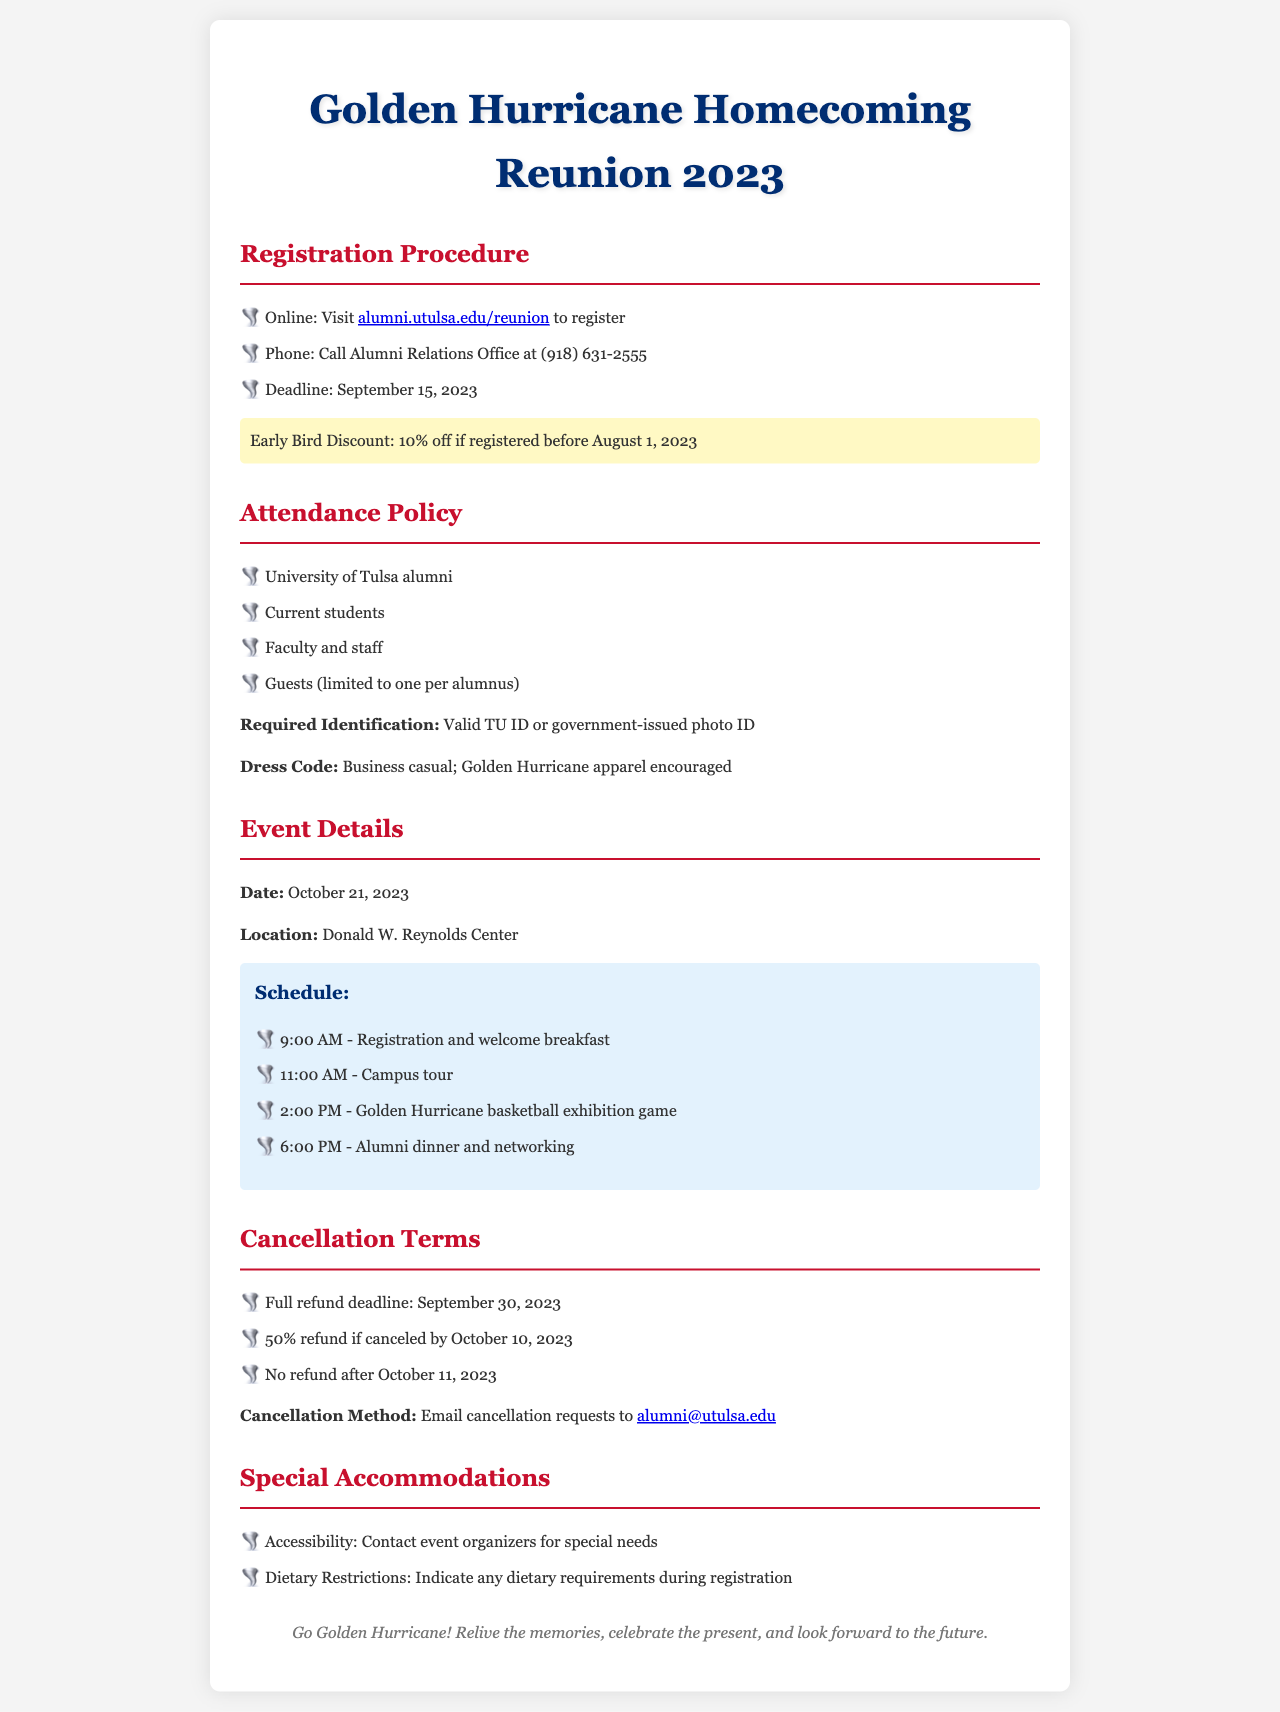What is the registration deadline? The registration deadline is clearly stated in the document, which is September 15, 2023.
Answer: September 15, 2023 Where can alumni register for the reunion? The document specifies that alumni can register online at a particular website. The website is alumni.utulsa.edu/reunion.
Answer: alumni.utulsa.edu/reunion What is the early bird discount percentage? The document mentions an early bird discount for those who register before a certain date, which is 10%.
Answer: 10% When is the full refund deadline? The document outlines the cancellation terms, including the full refund deadline on September 30, 2023.
Answer: September 30, 2023 What is required for identification at the event? The document specifies the type of identification required, stating a valid TU ID or government-issued photo ID is necessary.
Answer: Valid TU ID or government-issued photo ID What happens if I cancel after October 11, 2023? The cancellation terms explain that no refund will be issued if canceled after a specific date. The answer is no refund.
Answer: No refund What type of dress code is required? The document details the dress code, which is business casual with encouragement for Golden Hurricane apparel.
Answer: Business casual; Golden Hurricane apparel encouraged What time does the alumni dinner start? The schedule in the document lists the alumni dinner starting at a specific time, which is 6:00 PM.
Answer: 6:00 PM How should cancellation requests be submitted? The document describes the method for submitting cancellation requests, which is via email to a specific address.
Answer: Email cancellation requests to alumni@utulsa.edu 